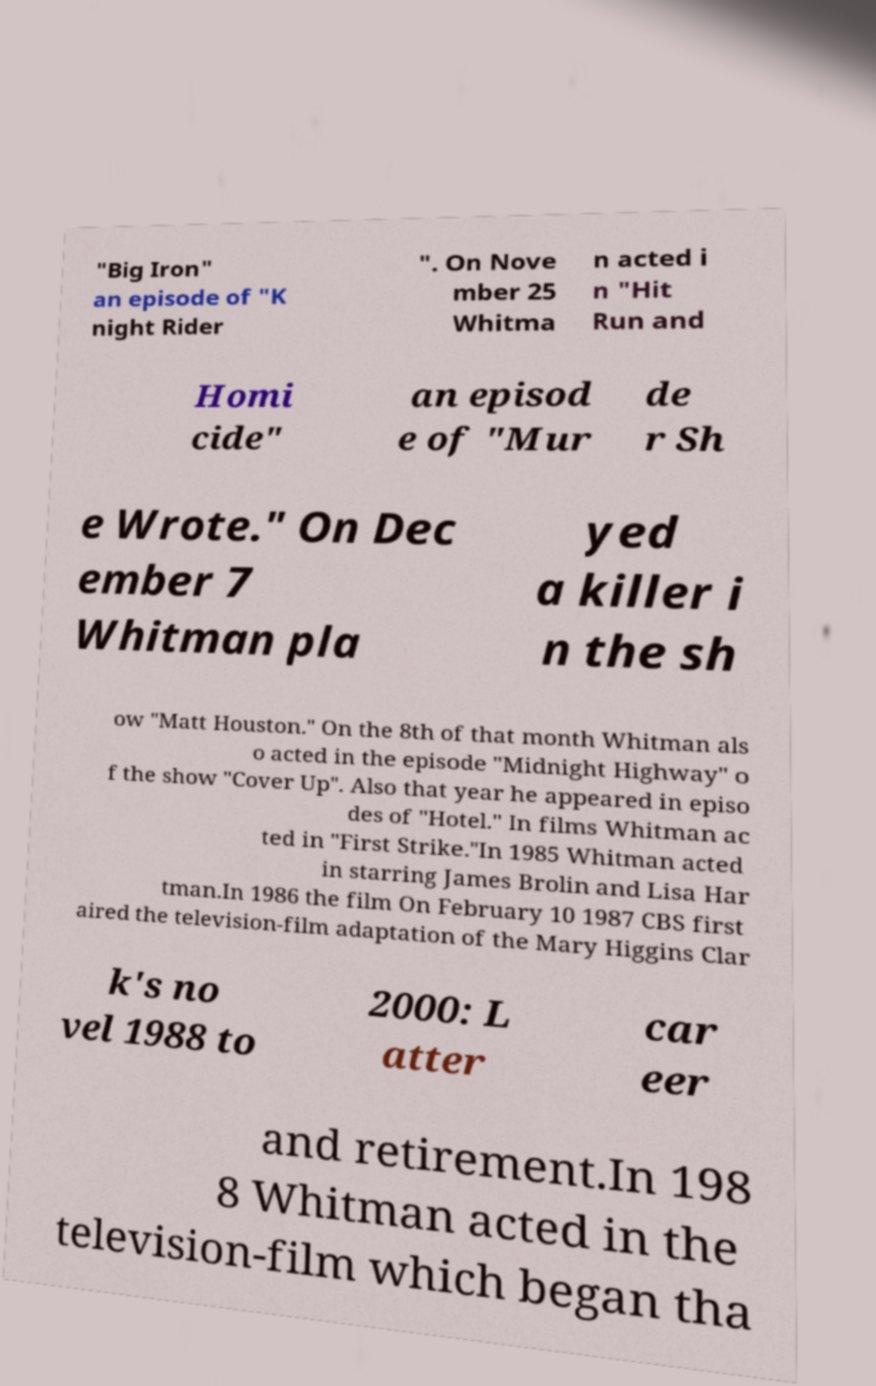Please read and relay the text visible in this image. What does it say? "Big Iron" an episode of "K night Rider ". On Nove mber 25 Whitma n acted i n "Hit Run and Homi cide" an episod e of "Mur de r Sh e Wrote." On Dec ember 7 Whitman pla yed a killer i n the sh ow "Matt Houston." On the 8th of that month Whitman als o acted in the episode "Midnight Highway" o f the show "Cover Up". Also that year he appeared in episo des of "Hotel." In films Whitman ac ted in "First Strike."In 1985 Whitman acted in starring James Brolin and Lisa Har tman.In 1986 the film On February 10 1987 CBS first aired the television-film adaptation of the Mary Higgins Clar k's no vel 1988 to 2000: L atter car eer and retirement.In 198 8 Whitman acted in the television-film which began tha 